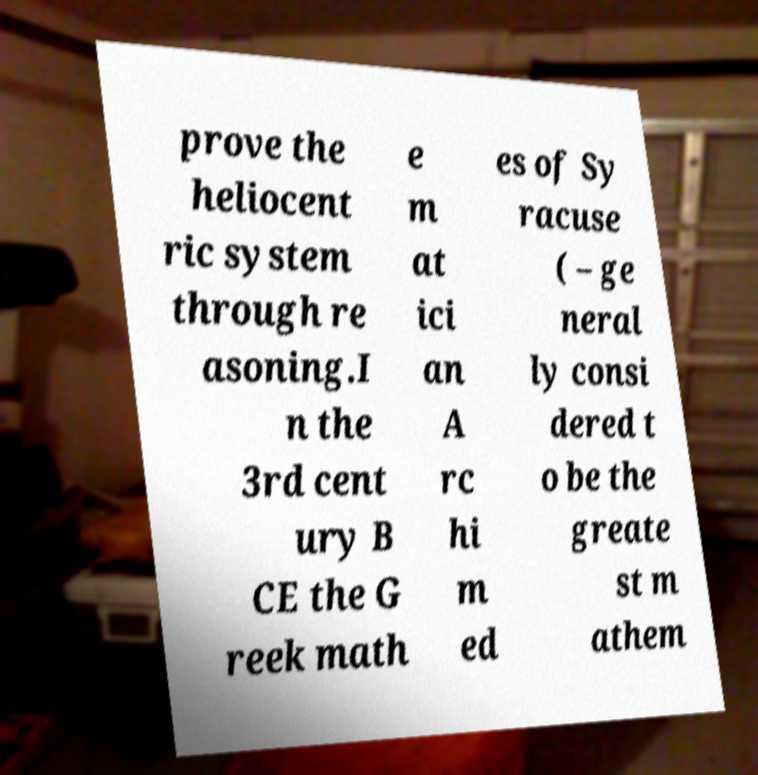Can you read and provide the text displayed in the image?This photo seems to have some interesting text. Can you extract and type it out for me? prove the heliocent ric system through re asoning.I n the 3rd cent ury B CE the G reek math e m at ici an A rc hi m ed es of Sy racuse ( – ge neral ly consi dered t o be the greate st m athem 